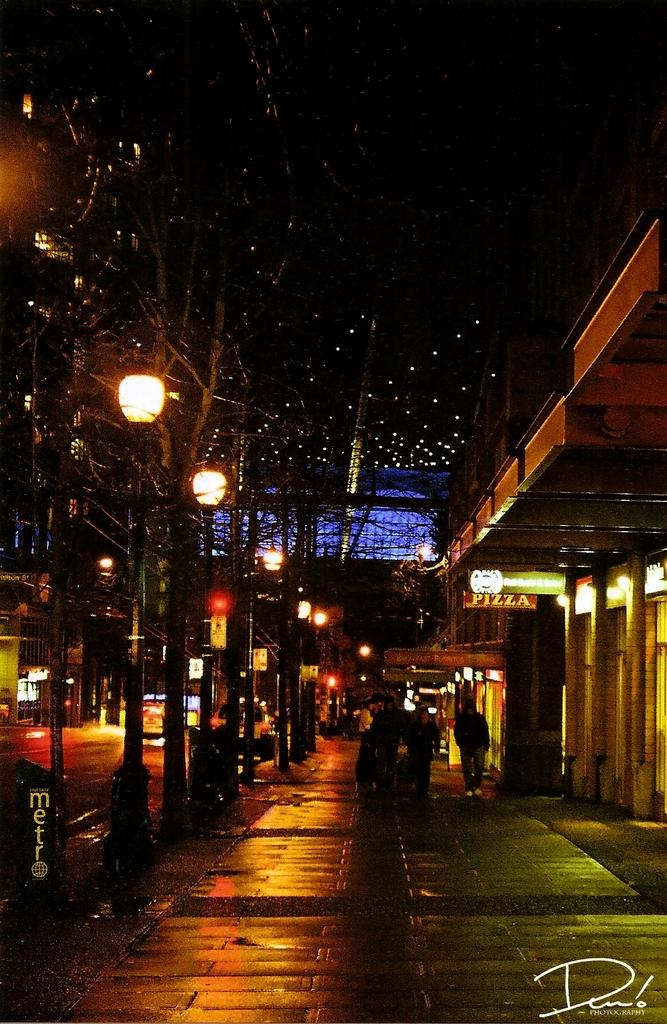How many persons are in the image? There are persons in the image. What objects can be seen in the image besides the persons? There are poles, lights, boards, and buildings in the image. What is the color of the background in the image? The background of the image is dark. Can you tell me how many kittens are playing on the street in the image? There are no kittens or streets present in the image; it features persons, poles, lights, boards, buildings, and a dark background. What type of zebra can be seen interacting with the persons in the image? There is no zebra present in the image; it only features persons, poles, lights, boards, buildings, and a dark background. 